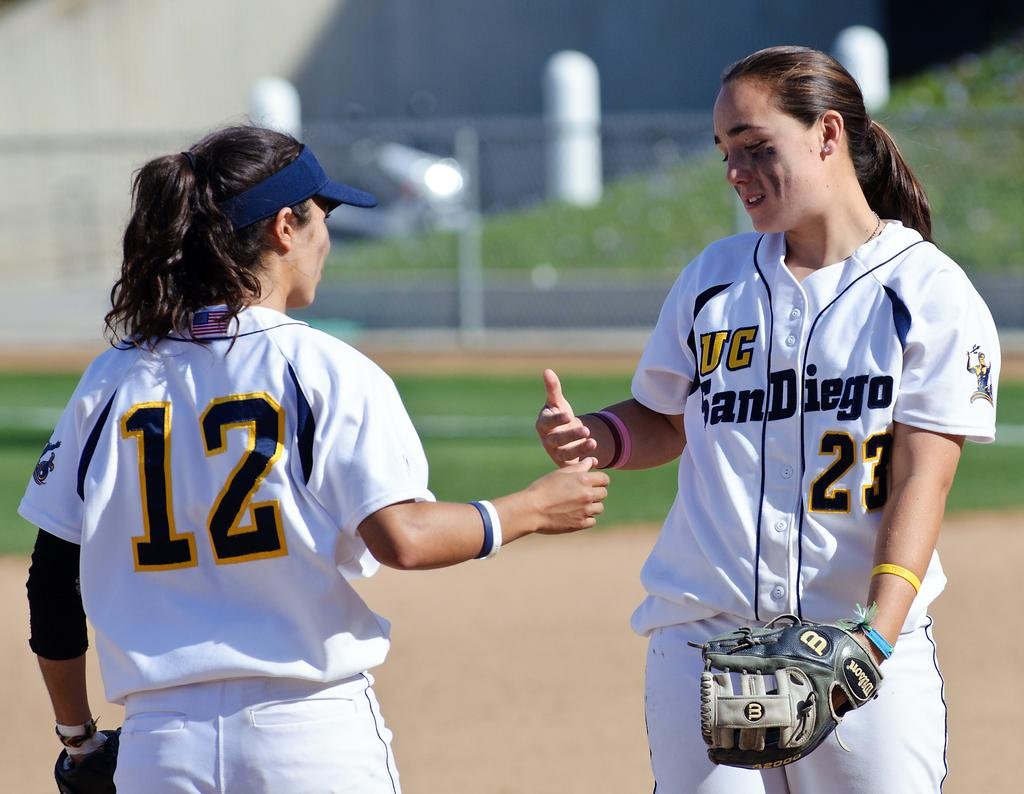<image>
Present a compact description of the photo's key features. Two female softball players talking with one girl facing this way and with UC San Diego on her shirt. 